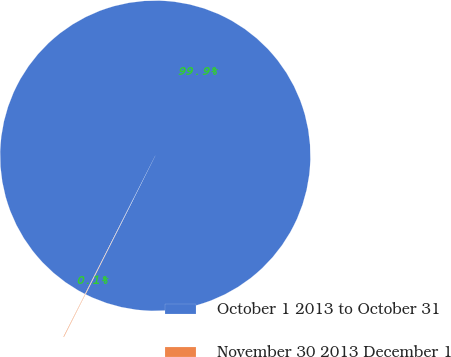Convert chart. <chart><loc_0><loc_0><loc_500><loc_500><pie_chart><fcel>October 1 2013 to October 31<fcel>November 30 2013 December 1<nl><fcel>99.94%<fcel>0.06%<nl></chart> 